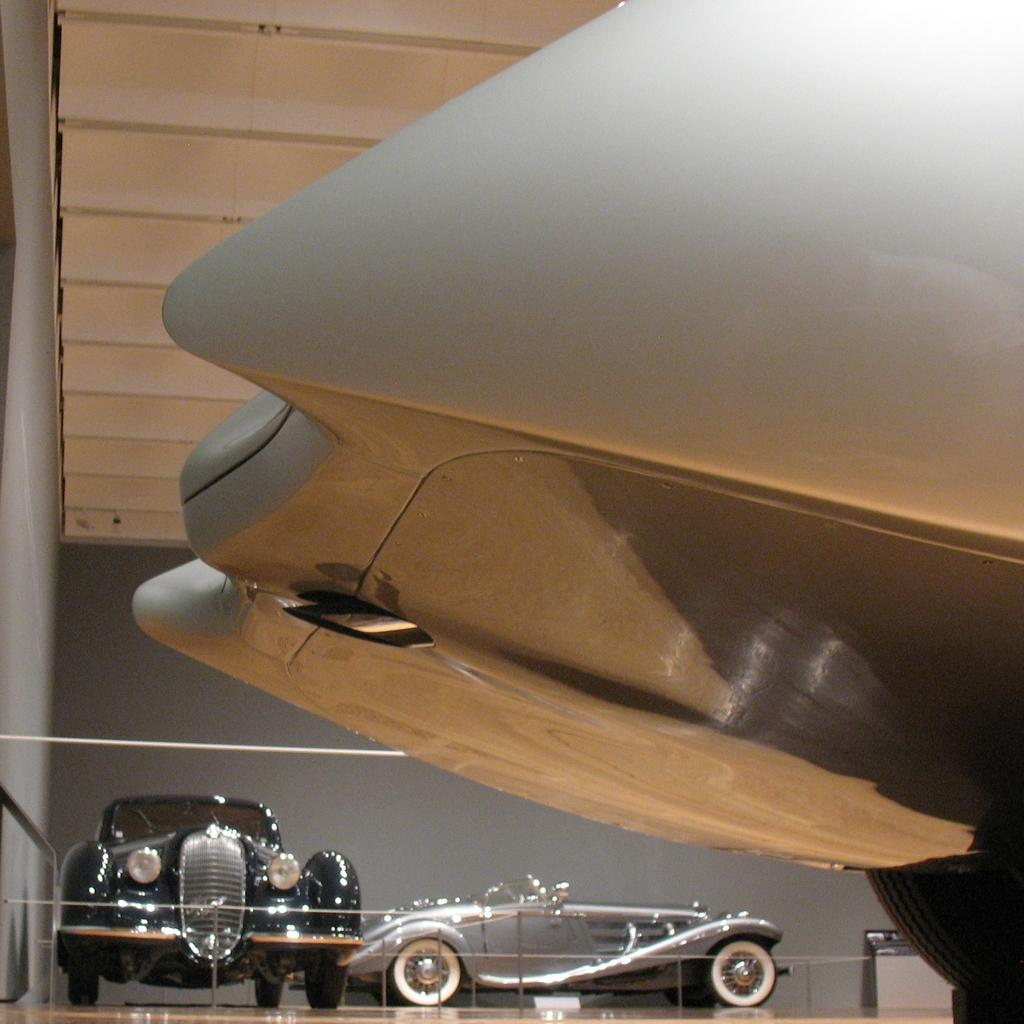How many cars are in the image? There are two cars in the image. Where are the cars located in relation to other objects? The cars are parked near a wall. What parts of the cars can be seen at the bottom of the image? The car's bonnet and wheel are visible at the bottom of the image. What structure is located at the top of the image? There is a shed at the top of the image. What object is on the left side of the image? There is a pole on the left side of the image. What type of seed is growing on the car's bonnet in the image? There is no seed growing on the car's bonnet in the image; it is a parked car with no plants or seeds present. 